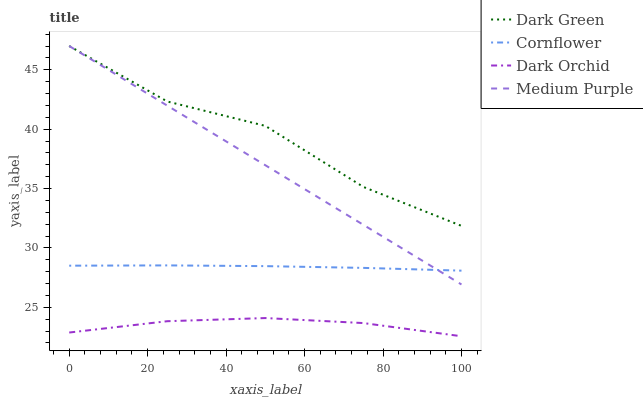Does Dark Orchid have the minimum area under the curve?
Answer yes or no. Yes. Does Dark Green have the maximum area under the curve?
Answer yes or no. Yes. Does Cornflower have the minimum area under the curve?
Answer yes or no. No. Does Cornflower have the maximum area under the curve?
Answer yes or no. No. Is Medium Purple the smoothest?
Answer yes or no. Yes. Is Dark Green the roughest?
Answer yes or no. Yes. Is Cornflower the smoothest?
Answer yes or no. No. Is Cornflower the roughest?
Answer yes or no. No. Does Dark Orchid have the lowest value?
Answer yes or no. Yes. Does Cornflower have the lowest value?
Answer yes or no. No. Does Dark Green have the highest value?
Answer yes or no. Yes. Does Cornflower have the highest value?
Answer yes or no. No. Is Dark Orchid less than Dark Green?
Answer yes or no. Yes. Is Medium Purple greater than Dark Orchid?
Answer yes or no. Yes. Does Medium Purple intersect Cornflower?
Answer yes or no. Yes. Is Medium Purple less than Cornflower?
Answer yes or no. No. Is Medium Purple greater than Cornflower?
Answer yes or no. No. Does Dark Orchid intersect Dark Green?
Answer yes or no. No. 